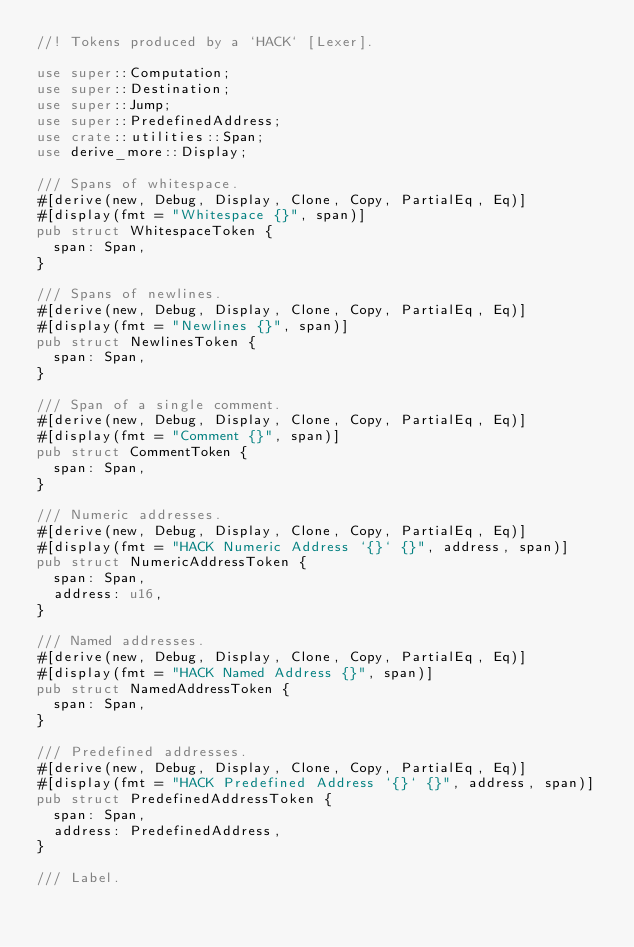<code> <loc_0><loc_0><loc_500><loc_500><_Rust_>//! Tokens produced by a `HACK` [Lexer].

use super::Computation;
use super::Destination;
use super::Jump;
use super::PredefinedAddress;
use crate::utilities::Span;
use derive_more::Display;

/// Spans of whitespace.
#[derive(new, Debug, Display, Clone, Copy, PartialEq, Eq)]
#[display(fmt = "Whitespace {}", span)]
pub struct WhitespaceToken {
  span: Span,
}

/// Spans of newlines.
#[derive(new, Debug, Display, Clone, Copy, PartialEq, Eq)]
#[display(fmt = "Newlines {}", span)]
pub struct NewlinesToken {
  span: Span,
}

/// Span of a single comment.
#[derive(new, Debug, Display, Clone, Copy, PartialEq, Eq)]
#[display(fmt = "Comment {}", span)]
pub struct CommentToken {
  span: Span,
}

/// Numeric addresses.
#[derive(new, Debug, Display, Clone, Copy, PartialEq, Eq)]
#[display(fmt = "HACK Numeric Address `{}` {}", address, span)]
pub struct NumericAddressToken {
  span: Span,
  address: u16,
}

/// Named addresses.
#[derive(new, Debug, Display, Clone, Copy, PartialEq, Eq)]
#[display(fmt = "HACK Named Address {}", span)]
pub struct NamedAddressToken {
  span: Span,
}

/// Predefined addresses.
#[derive(new, Debug, Display, Clone, Copy, PartialEq, Eq)]
#[display(fmt = "HACK Predefined Address `{}` {}", address, span)]
pub struct PredefinedAddressToken {
  span: Span,
  address: PredefinedAddress,
}

/// Label.</code> 